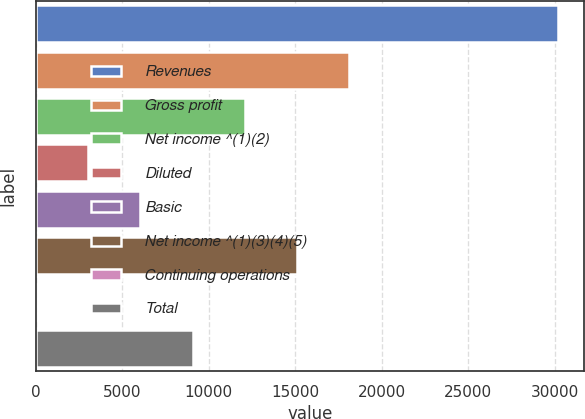Convert chart. <chart><loc_0><loc_0><loc_500><loc_500><bar_chart><fcel>Revenues<fcel>Gross profit<fcel>Net income ^(1)(2)<fcel>Diluted<fcel>Basic<fcel>Net income ^(1)(3)(4)(5)<fcel>Continuing operations<fcel>Total<nl><fcel>30216<fcel>18130<fcel>12087<fcel>3022.47<fcel>6043.97<fcel>15108.5<fcel>0.97<fcel>9065.47<nl></chart> 